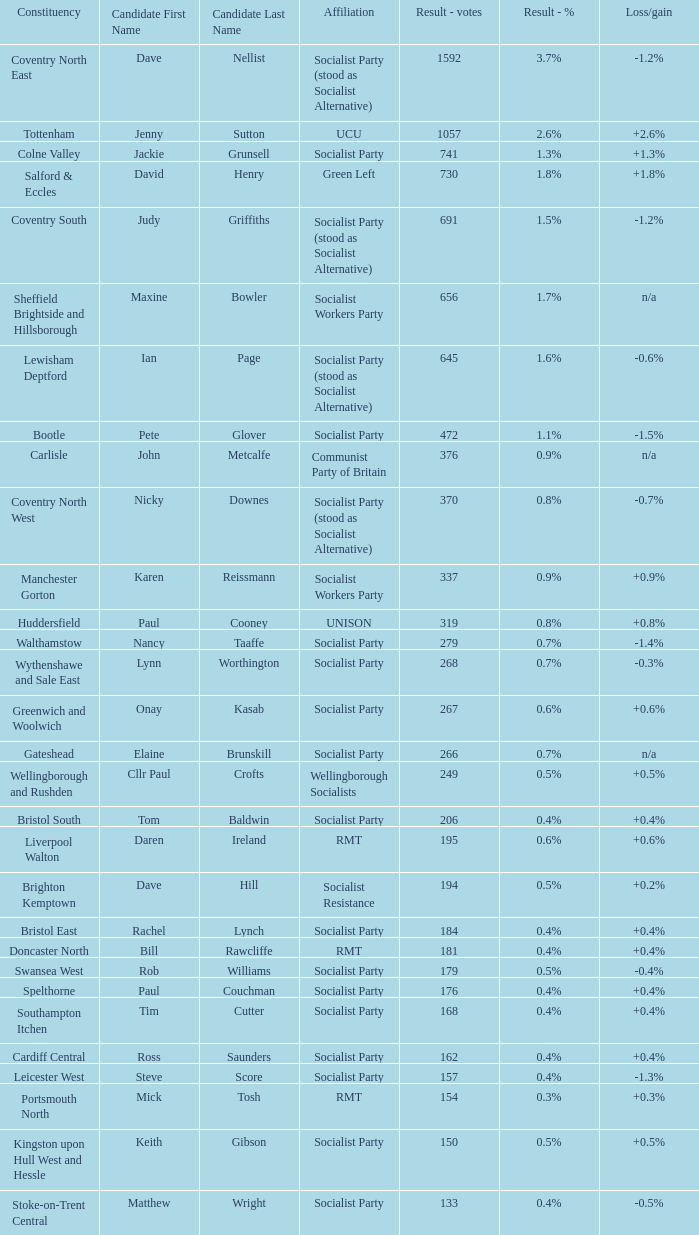What is the largest vote result if loss/gain is -0.5%? 133.0. 